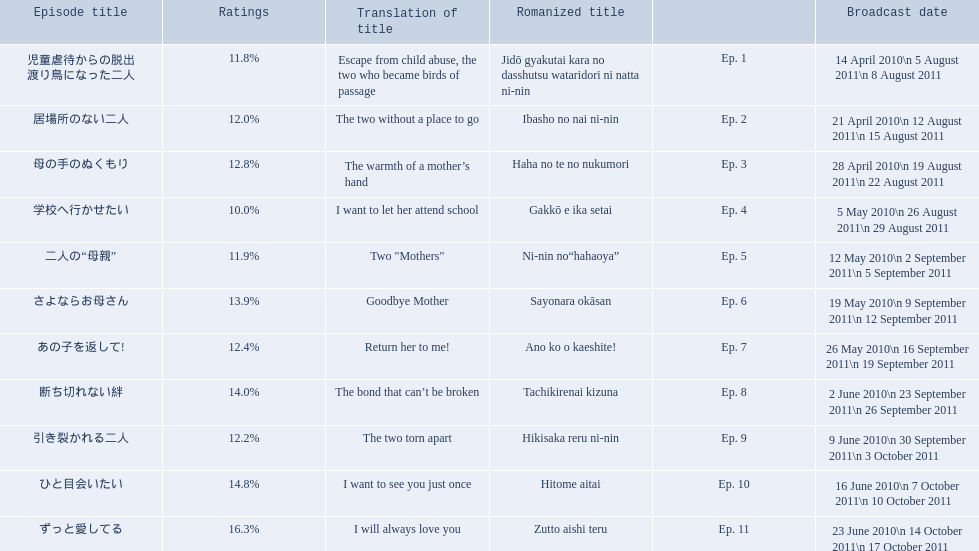What are the episode numbers? Ep. 1, Ep. 2, Ep. 3, Ep. 4, Ep. 5, Ep. 6, Ep. 7, Ep. 8, Ep. 9, Ep. 10, Ep. 11. What was the percentage of total ratings for episode 8? 14.0%. 